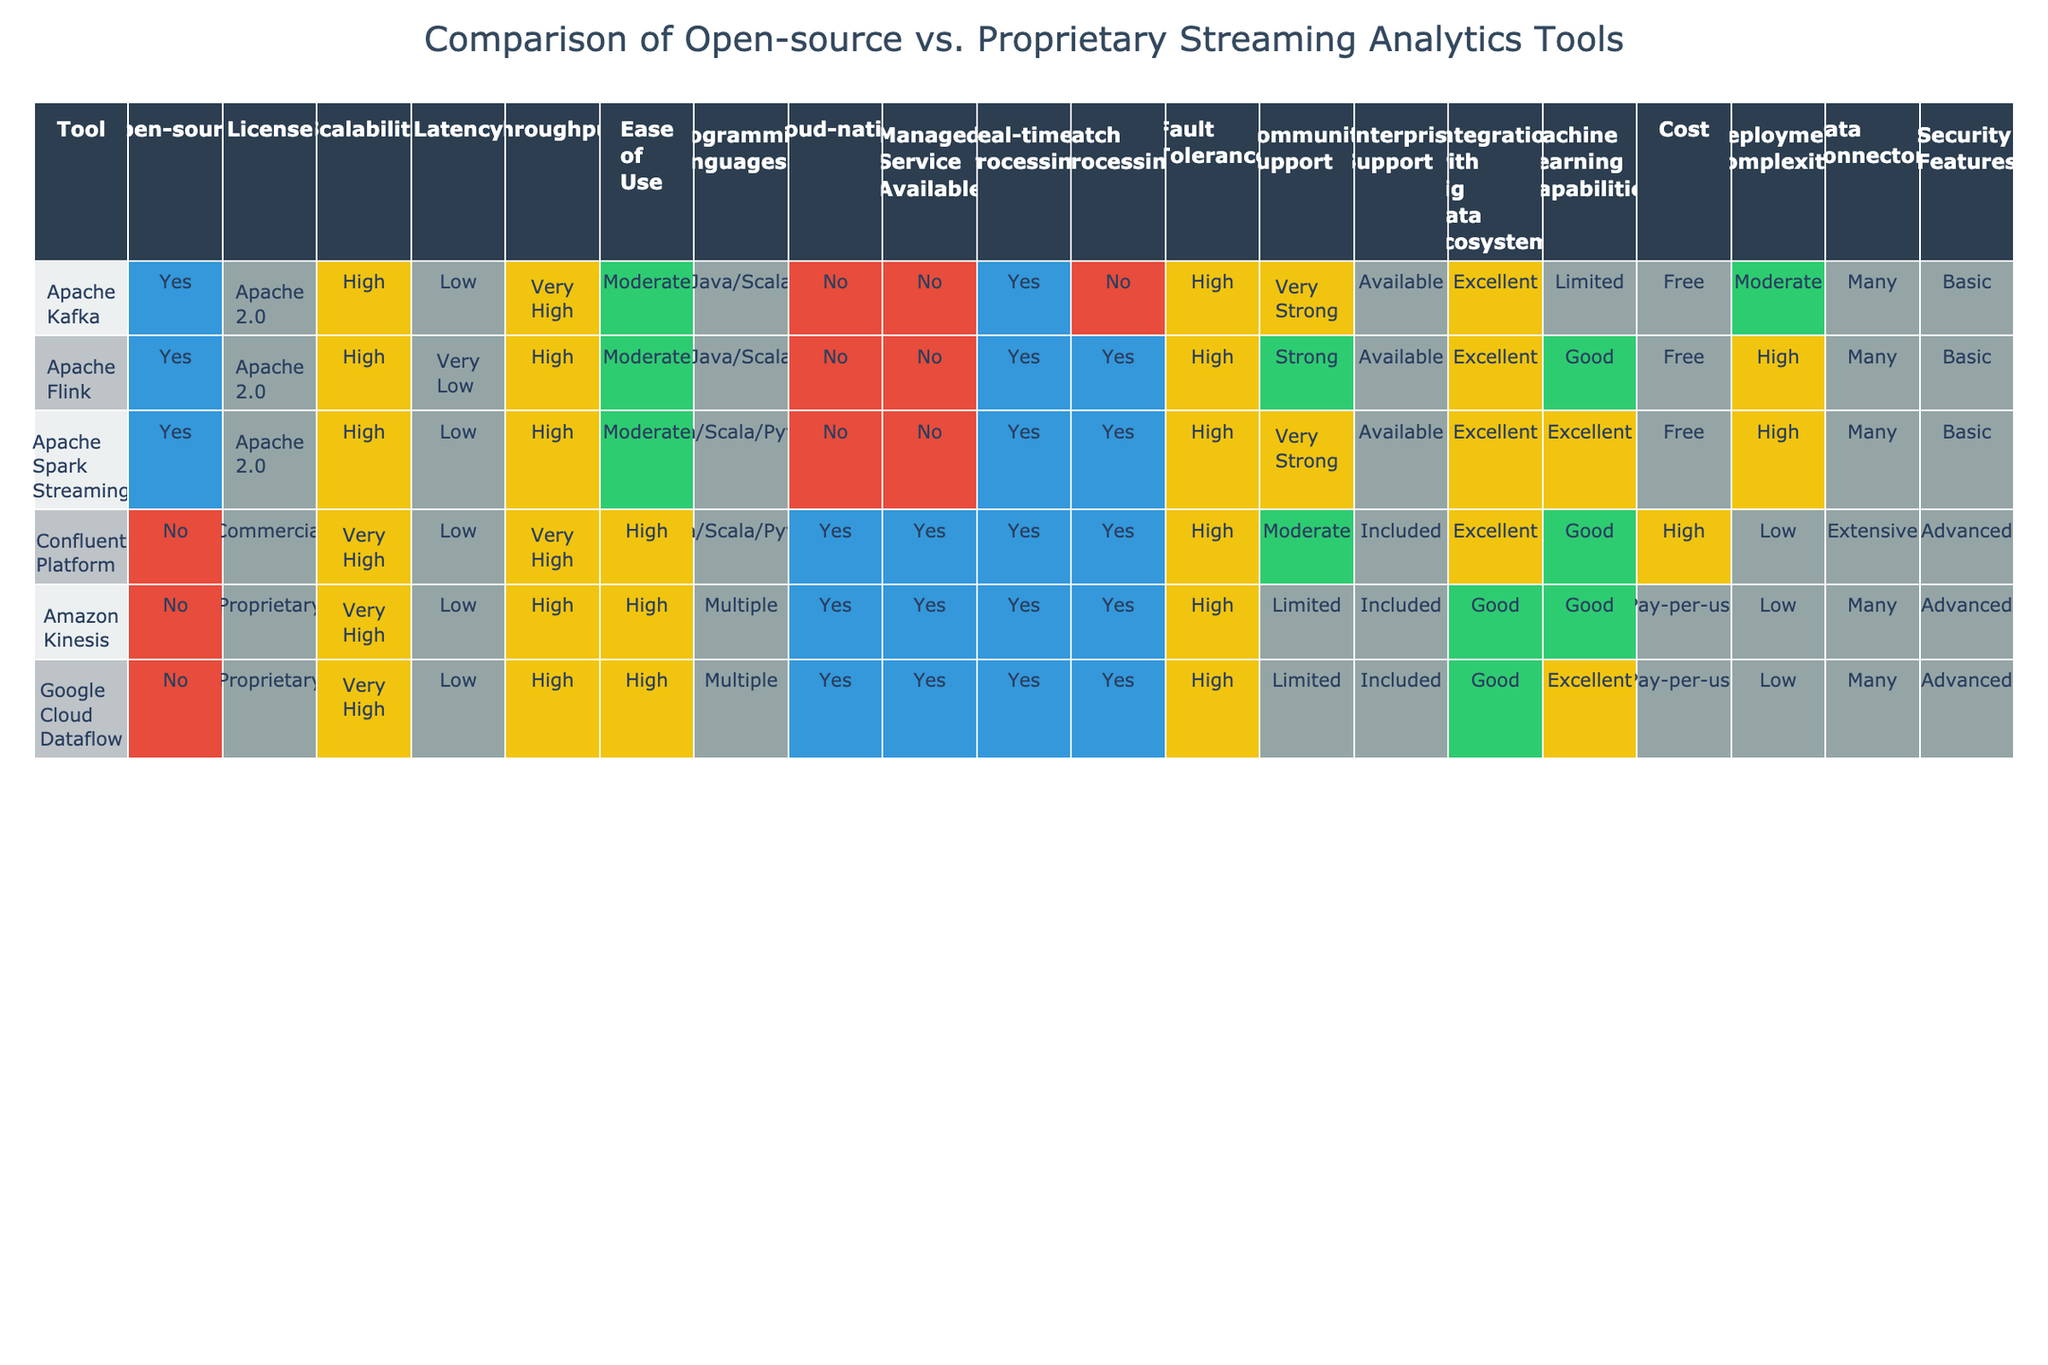What is the licensing type for Apache Flink? The table indicates that Apache Flink has an Apache 2.0 license listed under the License column.
Answer: Apache 2.0 Which tools offer managed services? By checking the Managed Service Available column, Amazon Kinesis, Google Cloud Dataflow, and Confluent Platform are marked as "Yes," indicating these tools offer managed services.
Answer: Amazon Kinesis, Google Cloud Dataflow, Confluent Platform How many tools can perform real-time processing? The Real-time Processing column shows that all listed tools (Apache Kafka, Apache Flink, Apache Spark Streaming, Confluent Platform, Amazon Kinesis, and Google Cloud Dataflow) are capable of real-time processing, as each one is marked "Yes."
Answer: 6 What is the average latency for proprietary tools? The latency values for proprietary tools (Confluent Platform, Amazon Kinesis, Google Cloud Dataflow) are all "Low." Therefore, the average latency is simply "Low" since all values are the same.
Answer: Low Is Apache Spark Streaming open-source? The Open-source column indicates that Apache Spark Streaming is listed as "Yes," confirming that it is an open-source tool.
Answer: Yes Which streaming analytics tool has the highest cost? The Cost column shows that the Confluent Platform has a "High" cost designation, while the others either are free or have pay-per-use pricing, indicating it is the most expensive option.
Answer: Confluent Platform Which tools provide strong community support? Looking at the Community Support column, Apache Kafka and Apache Spark Streaming are labeled as "Very Strong," whereas the others range from Strong to Limited.
Answer: Apache Kafka, Apache Spark Streaming How does the fault tolerance of Amazon Kinesis compare to that of Apache Kafka? Both Amazon Kinesis and Apache Kafka are listed as having "High" fault tolerance, so they have the same level of fault tolerance according to the table.
Answer: They are the same (High) What is the difference in deployment complexity between Amazon Kinesis and Apache Flink? The Deployment Complexity column shows that Amazon Kinesis is labeled "Low" while Apache Flink is labeled "High." Thus, the difference is that Amazon Kinesis has lower deployment complexity compared to Apache Flink.
Answer: Amazon Kinesis is easier to deploy than Apache Flink 